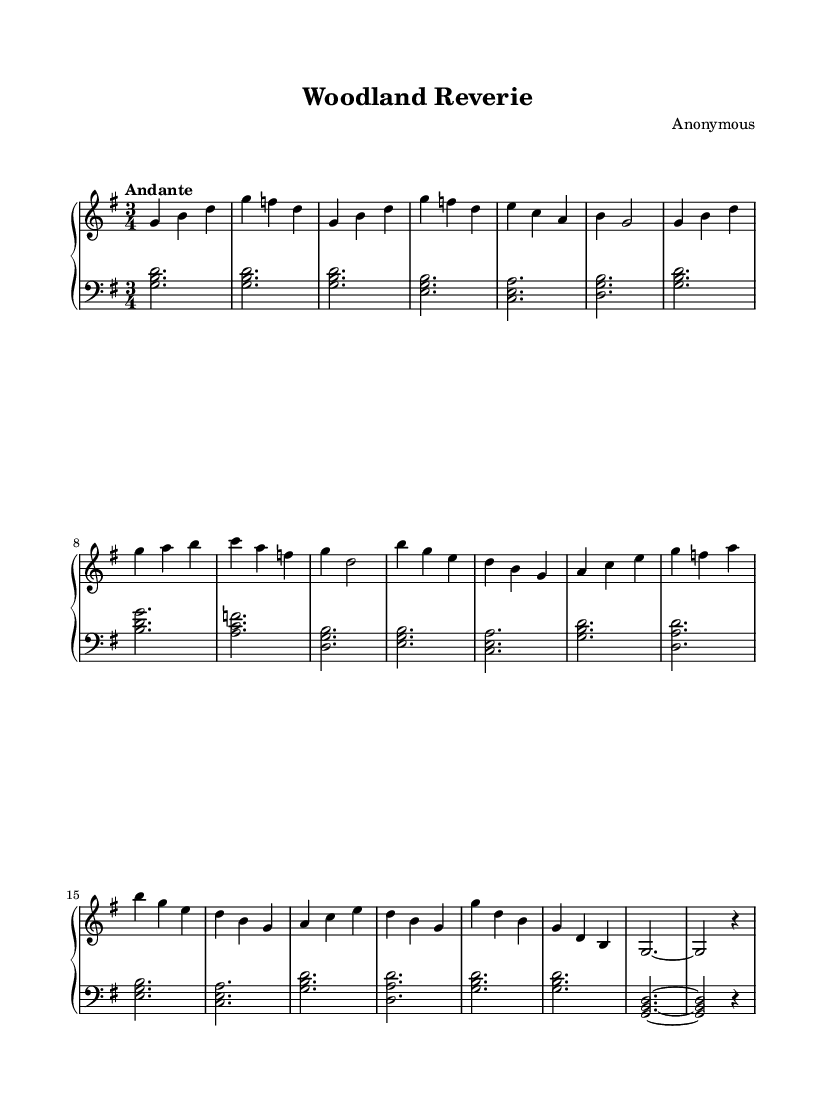What is the key signature of this music? The key signature is G major, which has one sharp (F#).
Answer: G major What is the time signature of this piece? The time signature is 3/4, which indicates three beats per measure.
Answer: 3/4 What is the tempo marking of this composition? The tempo marking is "Andante," which suggests a moderate pace.
Answer: Andante How many measures are in Section A? Section A has a total of six measures as indicated by the way the music is divided.
Answer: Six measures What is the last note of the Coda section? The last note of the Coda section is a rest, indicated by 'r4', which signifies a quarter rest following a note.
Answer: Rest What is the dynamic level indicated for the introduction? The music does not provide specific dynamics, but typically, an introduction is played softly to create a calm atmosphere.
Answer: Softly (assumed) Does this composition feature a contrasting section? Yes, Section B serves as a contrasting section to Section A by presenting different melodic and harmonic material.
Answer: Yes 